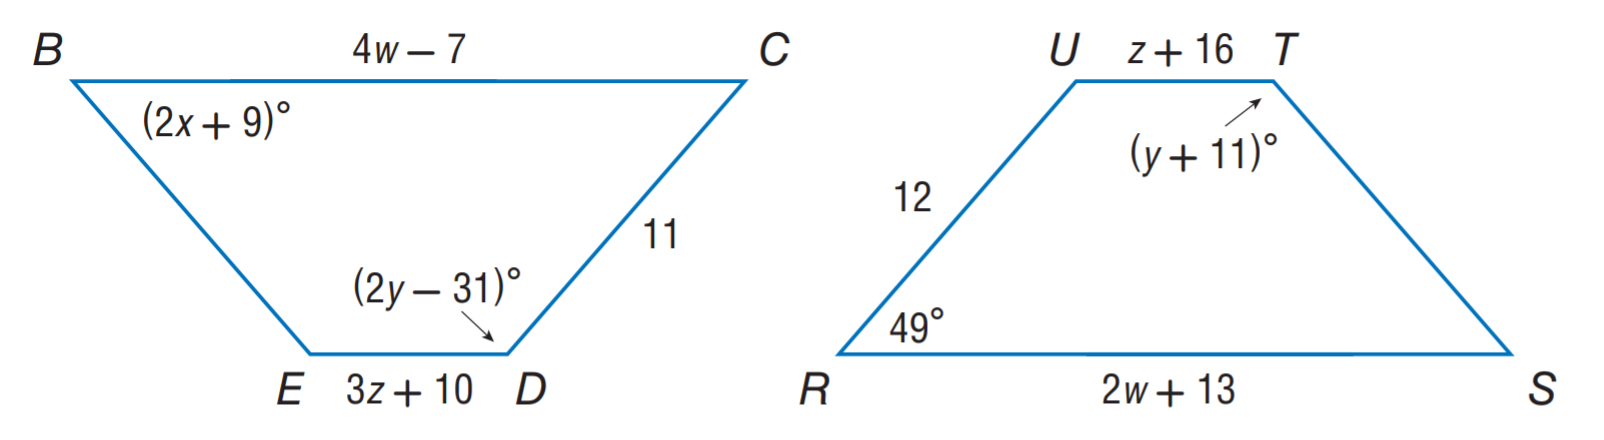Answer the mathemtical geometry problem and directly provide the correct option letter.
Question: Polygon B C D E \cong polygon R S T U. Find z.
Choices: A: 3 B: 10 C: 20 D: 42 A 